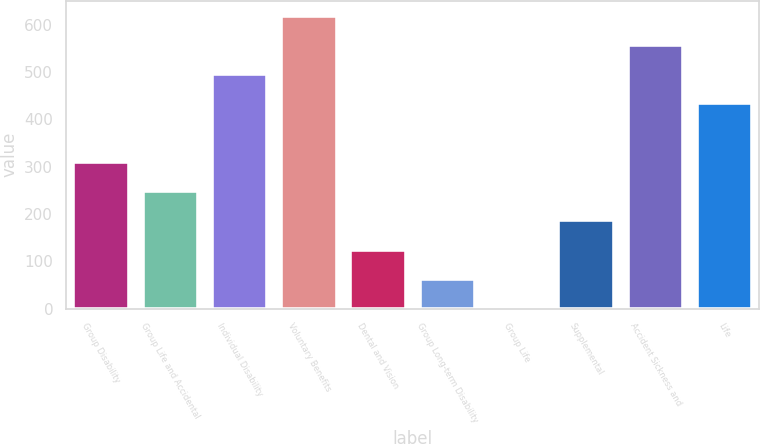Convert chart. <chart><loc_0><loc_0><loc_500><loc_500><bar_chart><fcel>Group Disability<fcel>Group Life and Accidental<fcel>Individual Disability<fcel>Voluntary Benefits<fcel>Dental and Vision<fcel>Group Long-term Disability<fcel>Group Life<fcel>Supplemental<fcel>Accident Sickness and<fcel>Life<nl><fcel>310.4<fcel>248.54<fcel>495.98<fcel>619.7<fcel>124.82<fcel>62.96<fcel>1.1<fcel>186.68<fcel>557.84<fcel>434.12<nl></chart> 